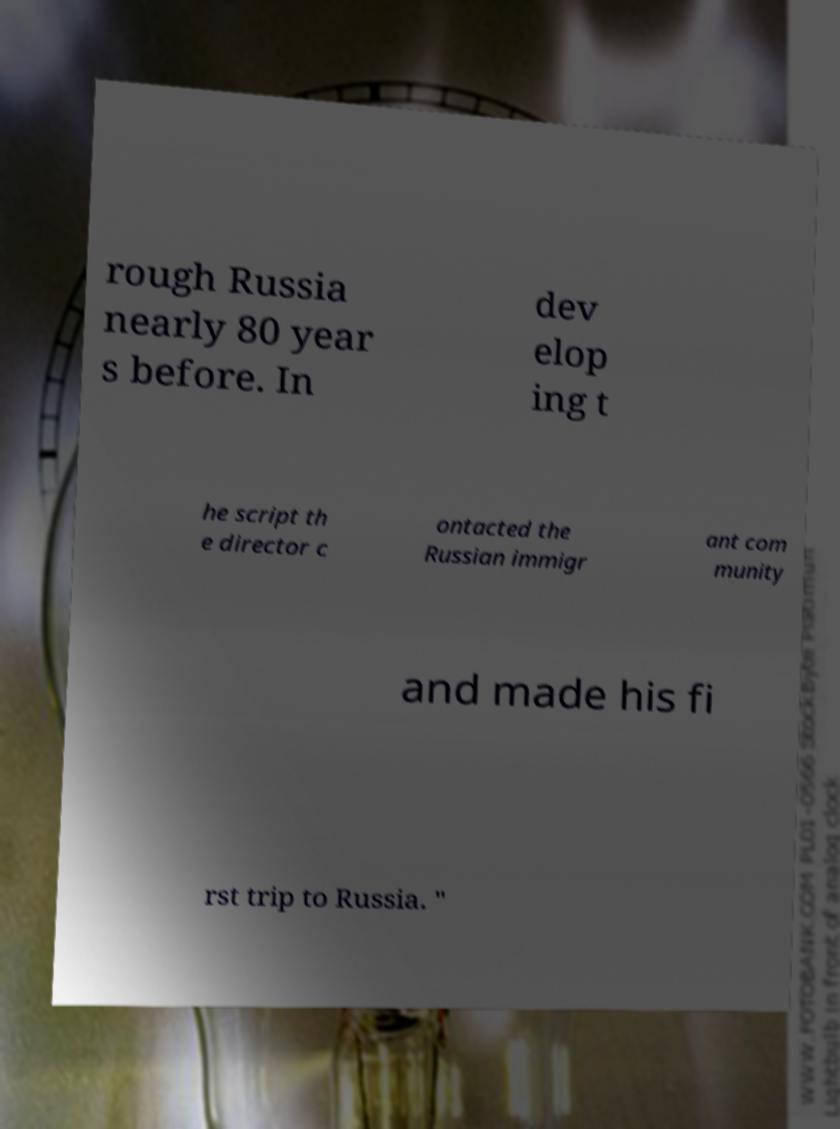Can you accurately transcribe the text from the provided image for me? rough Russia nearly 80 year s before. In dev elop ing t he script th e director c ontacted the Russian immigr ant com munity and made his fi rst trip to Russia. " 